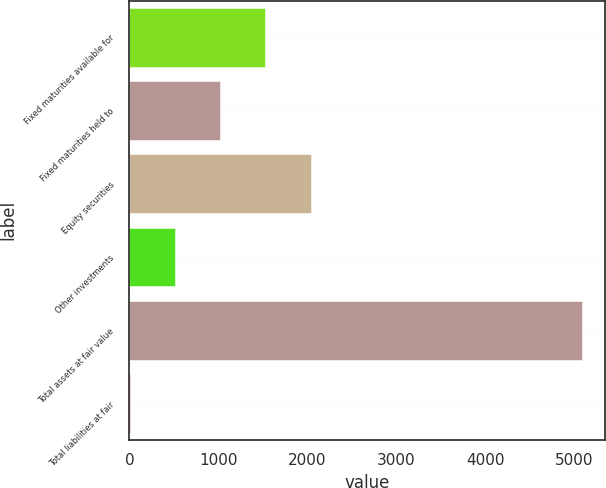<chart> <loc_0><loc_0><loc_500><loc_500><bar_chart><fcel>Fixed maturities available for<fcel>Fixed maturities held to<fcel>Equity securities<fcel>Other investments<fcel>Total assets at fair value<fcel>Total liabilities at fair<nl><fcel>1528.8<fcel>1020.2<fcel>2037.4<fcel>511.6<fcel>5089<fcel>3<nl></chart> 